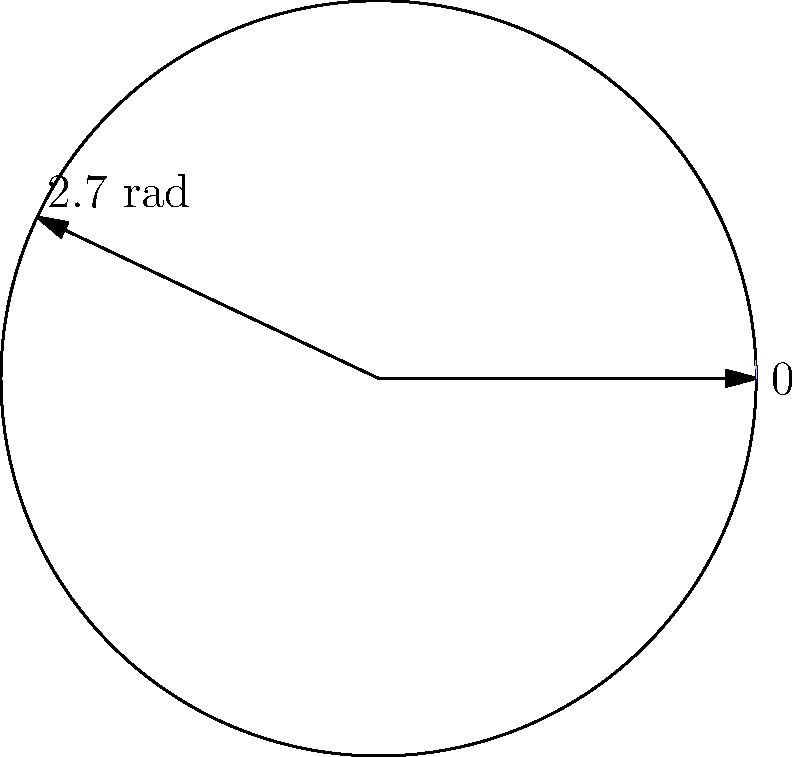In season 3 of "The Wire," Chris Bauer's character Andy Krawczyk had significant screen time. If his total screen time is represented by a sector of a circle with radius 10 cm and central angle 2.7 radians, what is the area of this sector in square centimeters? Round your answer to two decimal places. To find the area of a sector, we need to use the formula:

$$A = \frac{1}{2}r^2\theta$$

Where:
$A$ = Area of the sector
$r$ = Radius of the circle
$\theta$ = Central angle in radians

Given:
$r = 10$ cm
$\theta = 2.7$ radians

Let's substitute these values into the formula:

$$A = \frac{1}{2} \cdot 10^2 \cdot 2.7$$

$$A = \frac{1}{2} \cdot 100 \cdot 2.7$$

$$A = 50 \cdot 2.7$$

$$A = 135$$

Rounding to two decimal places:

$$A \approx 135.00\text{ cm}^2$$

Therefore, the area of the sector representing Chris Bauer's screen time in season 3 of "The Wire" is approximately 135.00 square centimeters.
Answer: 135.00 cm² 